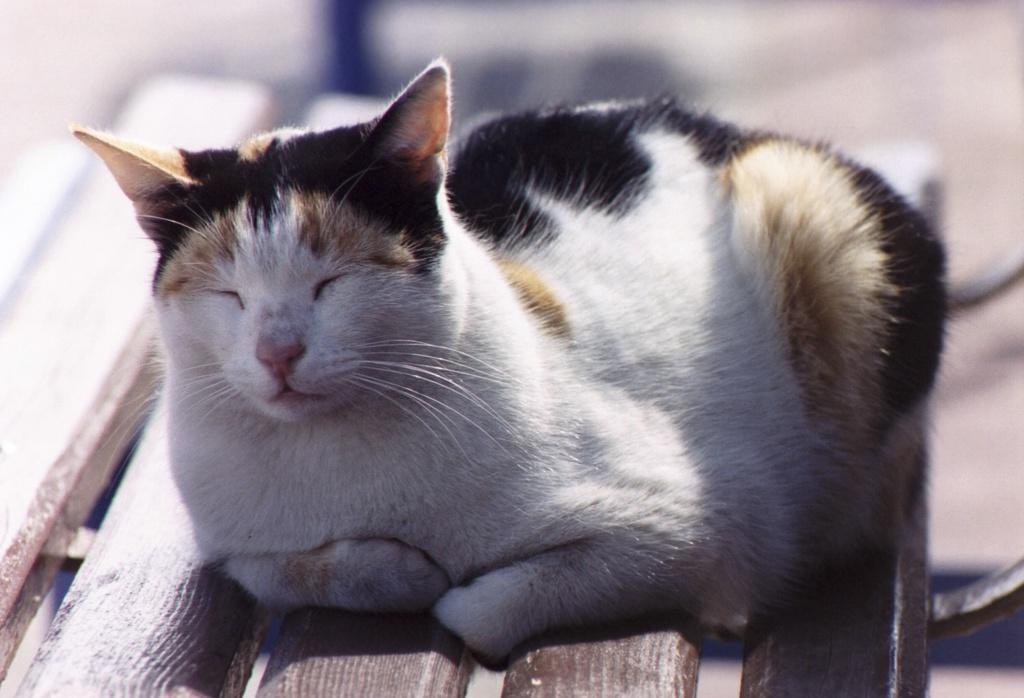Could you give a brief overview of what you see in this image? In this picture there is a cat in the center of the image, on a bench. 